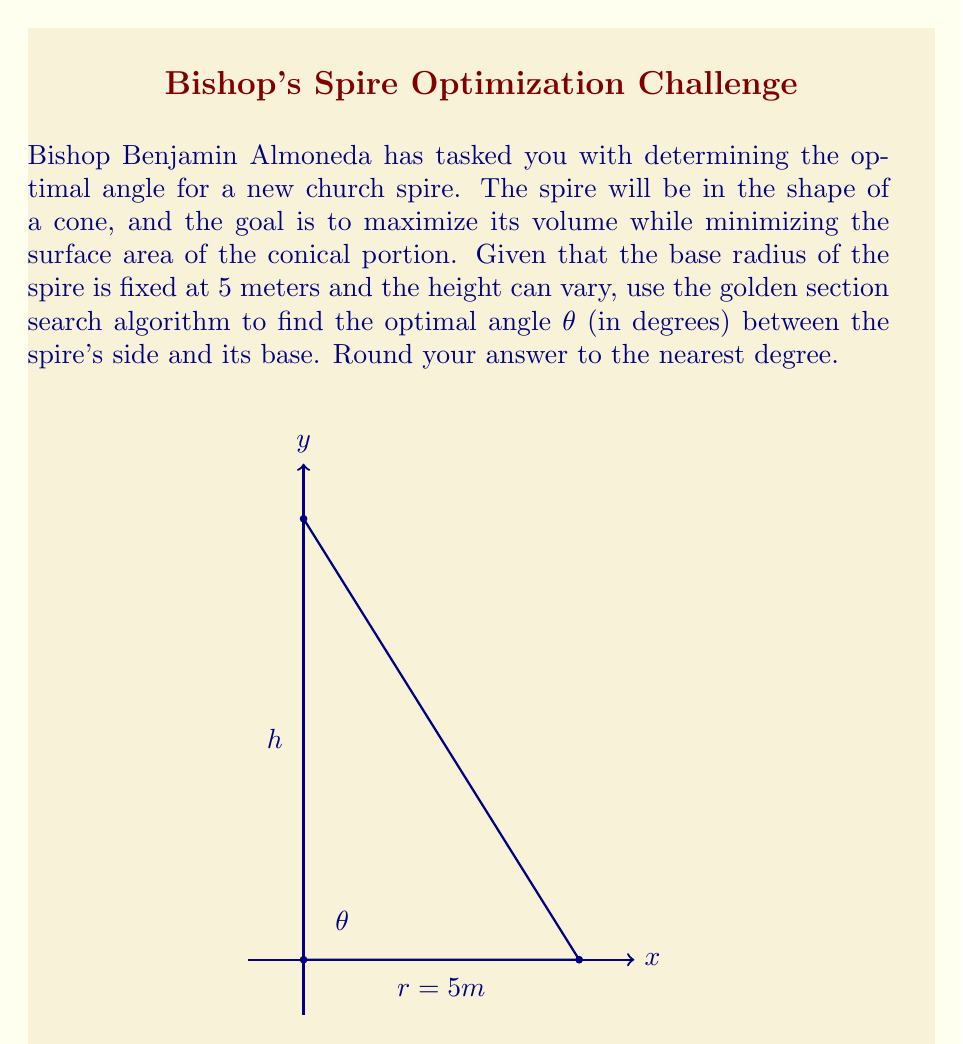Teach me how to tackle this problem. To solve this optimization problem, we'll follow these steps:

1) First, we need to express the volume and surface area in terms of θ:

   Volume: $V = \frac{1}{3}\pi r^2 h$
   Surface area (excluding base): $S = \pi r s$

   Where $r$ is the radius, $h$ is the height, and $s$ is the slant height.

2) We can express $h$ and $s$ in terms of $r$ and θ:
   $h = r \tan θ$
   $s = \frac{r}{\cos θ}$

3) Substituting these into our volume and surface area formulas:
   $V = \frac{1}{3}\pi r^3 \tan θ$
   $S = \pi r^2 \sec θ$

4) Our objective function will be to maximize volume while minimizing surface area. We can express this as:
   $f(θ) = \frac{V}{S} = \frac{\frac{1}{3}r \tan θ}{\sec θ} = \frac{1}{3}r \sin θ$

5) Given $r = 5$, our function becomes:
   $f(θ) = \frac{5}{3} \sin θ$

6) To find the maximum of this function, we can use the golden section search algorithm. This algorithm narrows down the search interval by using the golden ratio (φ ≈ 1.618) to choose test points.

7) We'll start with the interval [0°, 90°] and use the golden ratio to choose test points:
   $a = 0°$
   $b = 90°$
   $x_1 = b - (b-a)/φ ≈ 34.4°$
   $x_2 = a + (b-a)/φ ≈ 55.6°$

8) We evaluate $f(x_1)$ and $f(x_2)$ and continue narrowing the interval until we reach the desired precision.

9) After several iterations, the algorithm converges to θ ≈ 54.7°.

10) Rounding to the nearest degree, we get 55°.
Answer: 55° 